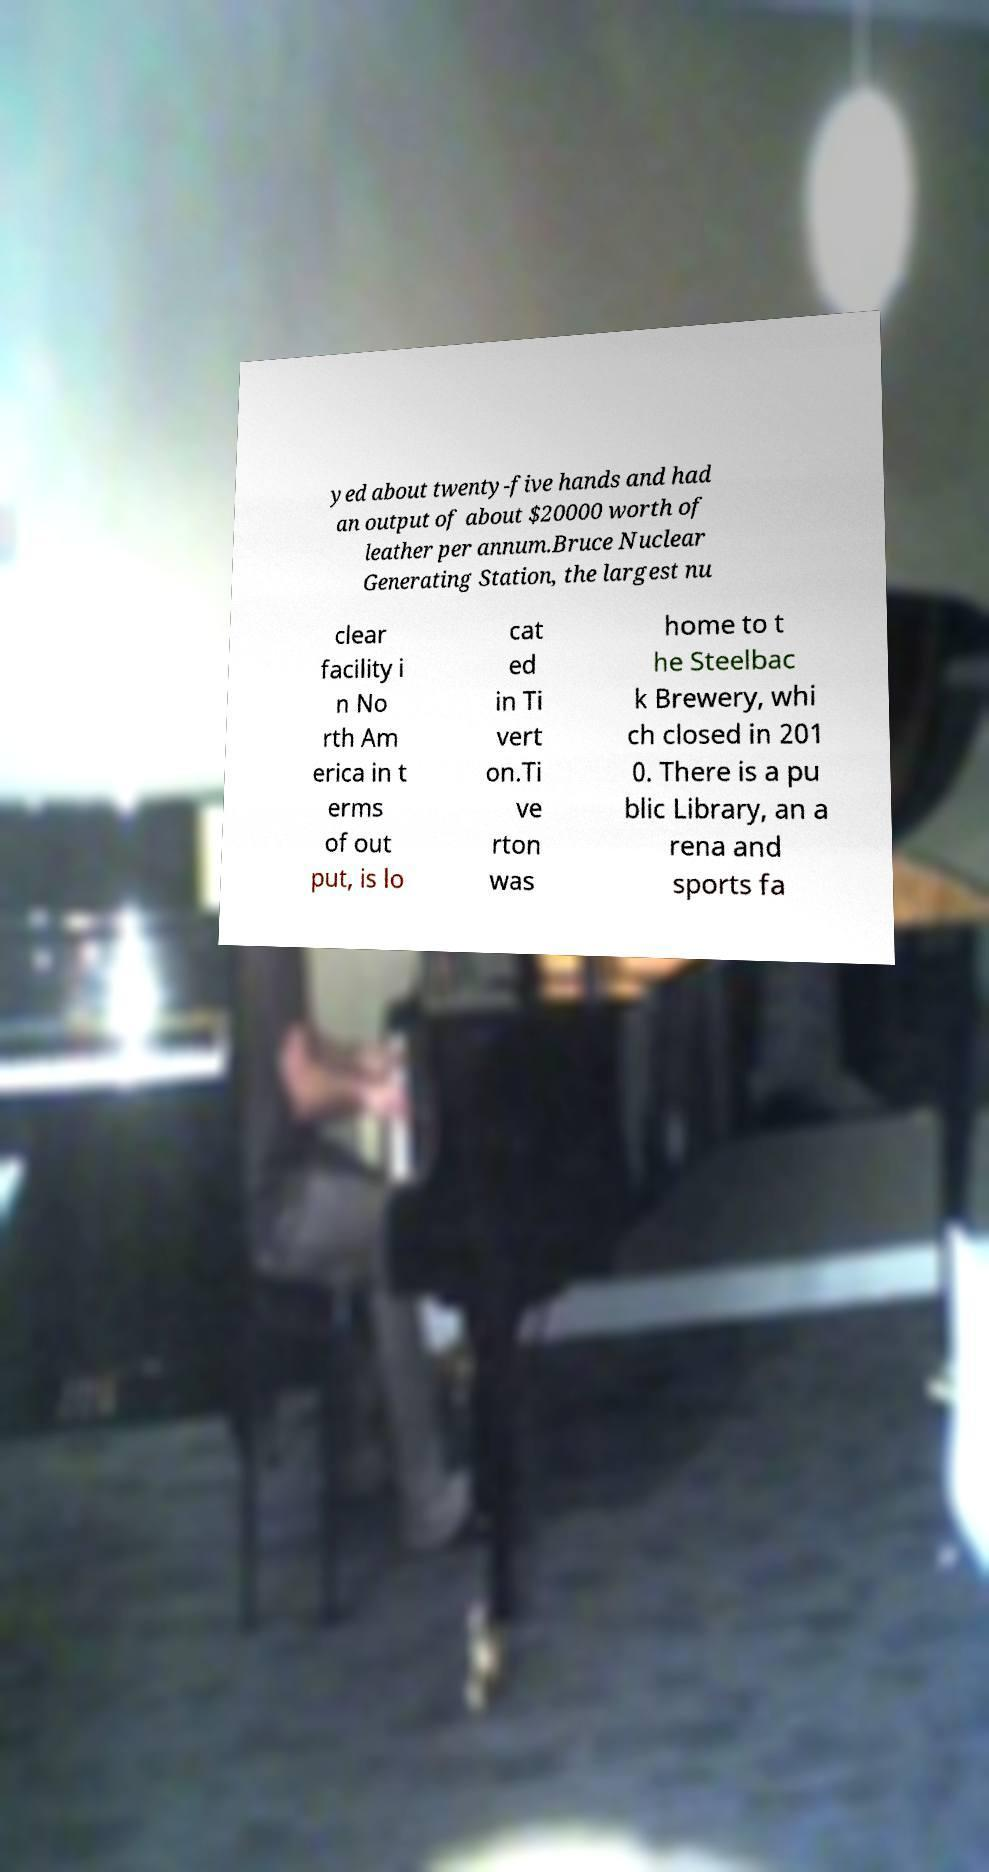Could you assist in decoding the text presented in this image and type it out clearly? yed about twenty-five hands and had an output of about $20000 worth of leather per annum.Bruce Nuclear Generating Station, the largest nu clear facility i n No rth Am erica in t erms of out put, is lo cat ed in Ti vert on.Ti ve rton was home to t he Steelbac k Brewery, whi ch closed in 201 0. There is a pu blic Library, an a rena and sports fa 